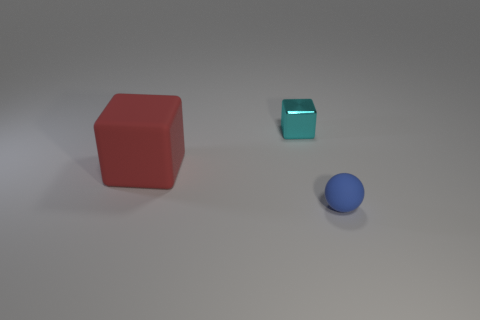Add 2 matte blocks. How many objects exist? 5 Subtract all spheres. How many objects are left? 2 Subtract 0 purple spheres. How many objects are left? 3 Subtract all large yellow metal cylinders. Subtract all cyan metallic things. How many objects are left? 2 Add 3 big things. How many big things are left? 4 Add 2 small matte spheres. How many small matte spheres exist? 3 